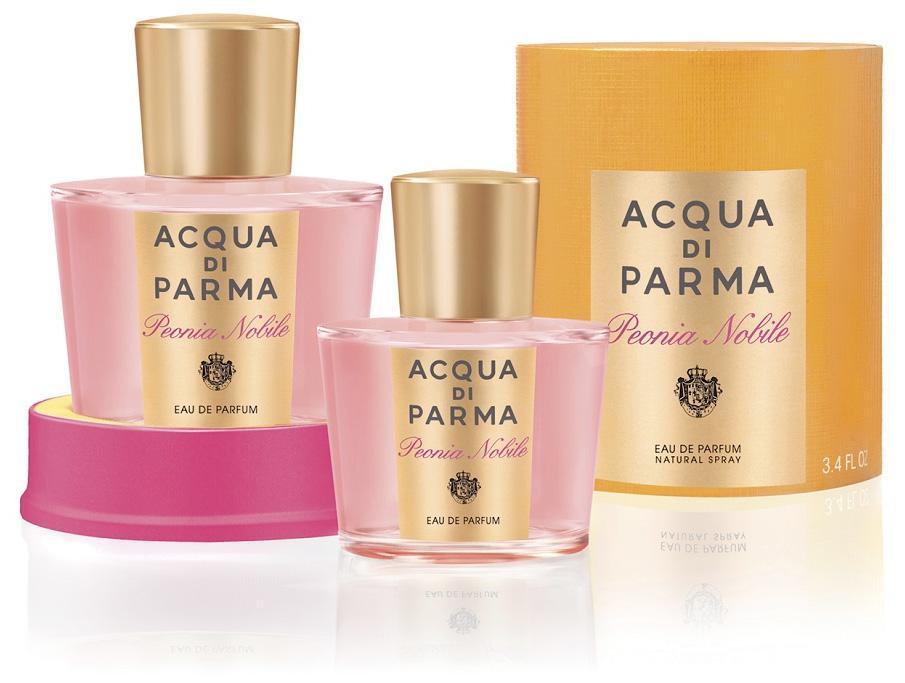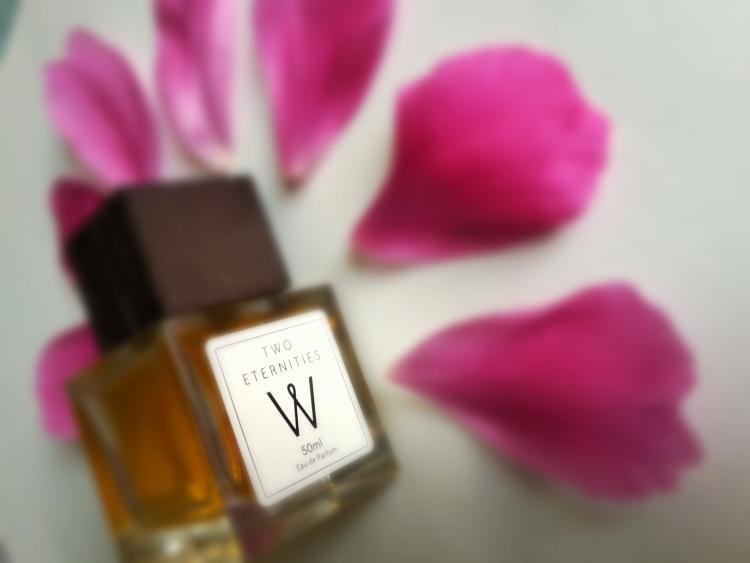The first image is the image on the left, the second image is the image on the right. Examine the images to the left and right. Is the description "There are pink flower petals behind the container in the image on the right." accurate? Answer yes or no. Yes. The first image is the image on the left, the second image is the image on the right. Examine the images to the left and right. Is the description "The right image contains no more than one perfume container." accurate? Answer yes or no. Yes. 